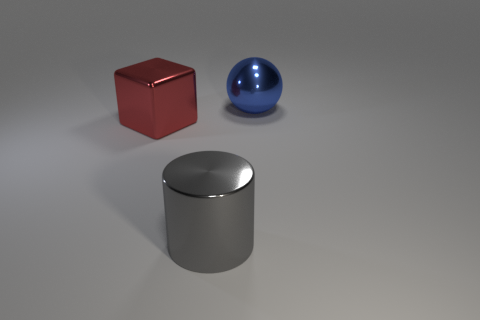The blue metallic object has what size?
Your response must be concise. Large. Is there anything else that is the same shape as the blue object?
Ensure brevity in your answer.  No. There is a large metal object that is right of the big gray object in front of the big shiny object that is left of the large gray cylinder; what is its color?
Offer a very short reply. Blue. How many large things are either blue rubber balls or metal cylinders?
Your response must be concise. 1. Is the number of metallic balls that are behind the big blue object the same as the number of cyan metal cylinders?
Make the answer very short. Yes. There is a large red metal object; are there any big gray things in front of it?
Ensure brevity in your answer.  Yes. How many shiny objects are big red spheres or big blue spheres?
Your response must be concise. 1. There is a big red cube; what number of large blue shiny balls are to the right of it?
Make the answer very short. 1. Is there a yellow block that has the same size as the red shiny object?
Provide a succinct answer. No. There is a large metal sphere; is it the same color as the large metallic object left of the gray metal cylinder?
Give a very brief answer. No. 